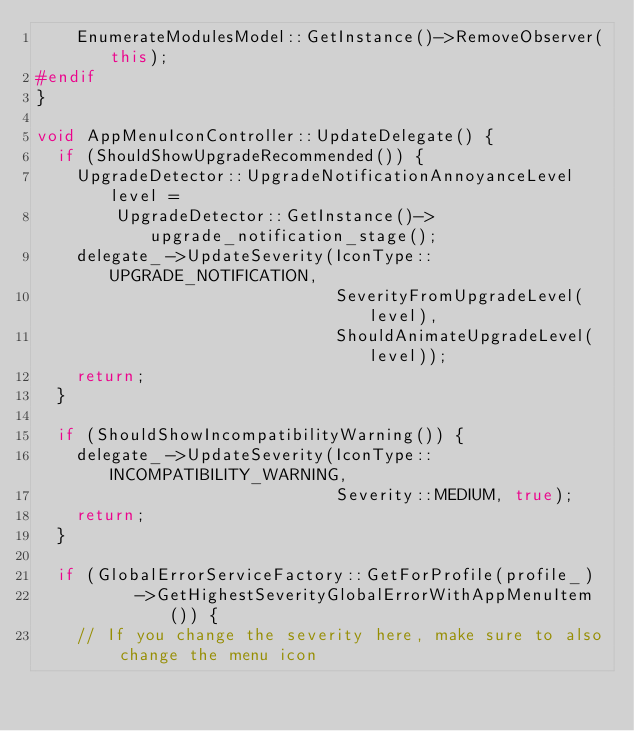<code> <loc_0><loc_0><loc_500><loc_500><_C++_>    EnumerateModulesModel::GetInstance()->RemoveObserver(this);
#endif
}

void AppMenuIconController::UpdateDelegate() {
  if (ShouldShowUpgradeRecommended()) {
    UpgradeDetector::UpgradeNotificationAnnoyanceLevel level =
        UpgradeDetector::GetInstance()->upgrade_notification_stage();
    delegate_->UpdateSeverity(IconType::UPGRADE_NOTIFICATION,
                              SeverityFromUpgradeLevel(level),
                              ShouldAnimateUpgradeLevel(level));
    return;
  }

  if (ShouldShowIncompatibilityWarning()) {
    delegate_->UpdateSeverity(IconType::INCOMPATIBILITY_WARNING,
                              Severity::MEDIUM, true);
    return;
  }

  if (GlobalErrorServiceFactory::GetForProfile(profile_)
          ->GetHighestSeverityGlobalErrorWithAppMenuItem()) {
    // If you change the severity here, make sure to also change the menu icon</code> 